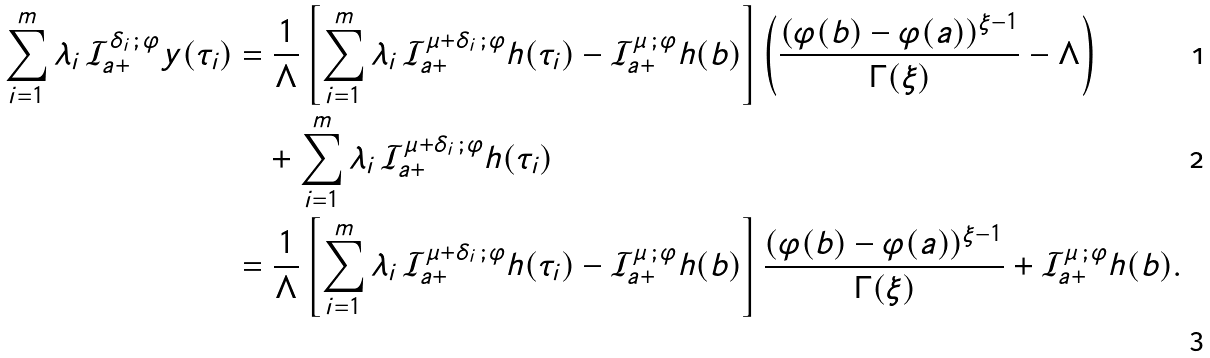<formula> <loc_0><loc_0><loc_500><loc_500>\sum _ { i = 1 } ^ { m } \lambda _ { i } \, \mathcal { I } _ { a + } ^ { \delta _ { i } \, ; \, \varphi } y ( \tau _ { i } ) & = \frac { 1 } { \Lambda } \left [ \sum _ { i = 1 } ^ { m } \lambda _ { i } \, \mathcal { I } _ { a + } ^ { \mu + \delta _ { i } \, ; \, \varphi } h ( \tau _ { i } ) - \mathcal { I } _ { a + } ^ { \mu \, ; \, \varphi } h ( b ) \right ] \left ( \frac { ( \varphi ( b ) - \varphi ( a ) ) ^ { \xi - 1 } } { \Gamma ( \xi ) } - \Lambda \right ) \\ & \quad + \sum _ { i = 1 } ^ { m } \lambda _ { i } \, \mathcal { I } _ { a + } ^ { \mu + \delta _ { i } \, ; \, \varphi } h ( \tau _ { i } ) \\ & = \frac { 1 } { \Lambda } \left [ \sum _ { i = 1 } ^ { m } \lambda _ { i } \, \mathcal { I } _ { a + } ^ { \mu + \delta _ { i } \, ; \, \varphi } h ( \tau _ { i } ) - \mathcal { I } _ { a + } ^ { \mu \, ; \, \varphi } h ( b ) \right ] \frac { ( \varphi ( b ) - \varphi ( a ) ) ^ { \xi - 1 } } { \Gamma ( \xi ) } + \mathcal { I } _ { a + } ^ { \mu \, ; \, \varphi } h ( b ) .</formula> 